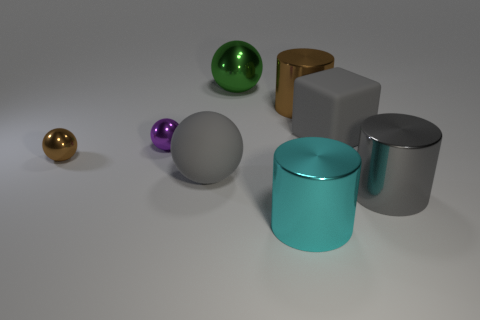Subtract all green spheres. Subtract all brown cylinders. How many spheres are left? 3 Add 1 tiny spheres. How many objects exist? 9 Subtract all cubes. How many objects are left? 7 Add 4 yellow spheres. How many yellow spheres exist? 4 Subtract 0 yellow balls. How many objects are left? 8 Subtract all brown things. Subtract all large metallic objects. How many objects are left? 2 Add 2 small brown objects. How many small brown objects are left? 3 